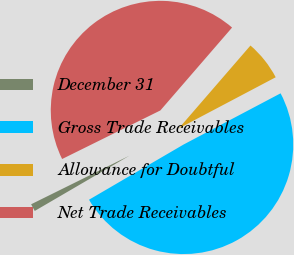Convert chart to OTSL. <chart><loc_0><loc_0><loc_500><loc_500><pie_chart><fcel>December 31<fcel>Gross Trade Receivables<fcel>Allowance for Doubtful<fcel>Net Trade Receivables<nl><fcel>1.1%<fcel>49.32%<fcel>5.92%<fcel>43.66%<nl></chart> 